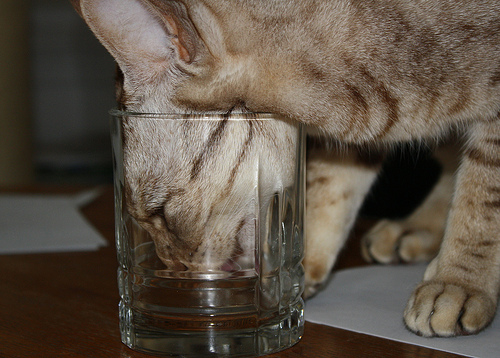<image>
Is there a cat in the glass? Yes. The cat is contained within or inside the glass, showing a containment relationship. Is there a cat next to the glass? No. The cat is not positioned next to the glass. They are located in different areas of the scene. 